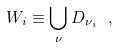Convert formula to latex. <formula><loc_0><loc_0><loc_500><loc_500>W _ { i } \equiv \bigcup _ { \nu } D _ { \nu _ { i } } \ ,</formula> 